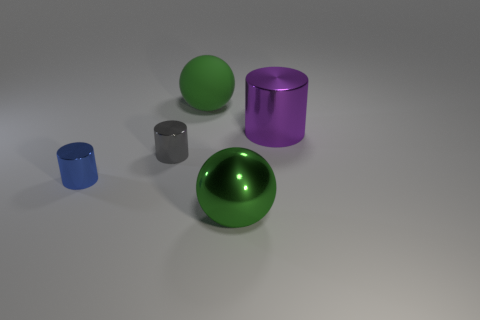Are there any large green shiny objects in front of the purple shiny cylinder?
Offer a very short reply. Yes. Are there any small blue metallic things that have the same shape as the green metallic object?
Your answer should be compact. No. There is a big green object to the left of the large shiny sphere; is it the same shape as the green object in front of the rubber ball?
Provide a succinct answer. Yes. Are there any red rubber things of the same size as the matte sphere?
Provide a succinct answer. No. Are there an equal number of green metallic objects that are to the right of the big purple metallic thing and big matte things that are to the left of the rubber ball?
Provide a succinct answer. Yes. Do the object to the left of the tiny gray shiny thing and the green ball that is in front of the purple metal thing have the same material?
Keep it short and to the point. Yes. How many other things are the same color as the large metal sphere?
Your answer should be compact. 1. Do the rubber object and the metallic ball have the same color?
Provide a succinct answer. Yes. What number of cyan metallic cubes are there?
Provide a succinct answer. 0. What material is the purple cylinder in front of the green thing that is behind the large shiny ball made of?
Offer a terse response. Metal. 